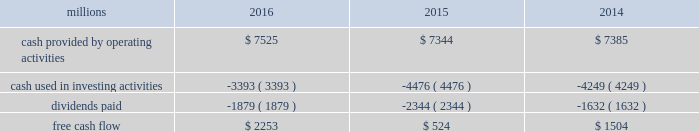To , rather than as a substitute for , cash provided by operating activities .
The table reconciles cash provided by operating activities ( gaap measure ) to free cash flow ( non-gaap measure ) : .
2017 outlook f0b7 safety 2013 operating a safe railroad benefits all our constituents : our employees , customers , shareholders and the communities we serve .
We will continue using a multi-faceted approach to safety , utilizing technology , risk assessment , training and employee engagement , quality control , and targeted capital investments .
We will continue using and expanding the deployment of total safety culture and courage to care throughout our operations , which allows us to identify and implement best practices for employee and operational safety .
We will continue our efforts to increase detection of rail defects ; improve or close crossings ; and educate the public and law enforcement agencies about crossing safety through a combination of our own programs ( including risk assessment strategies ) , industry programs and local community activities across our network .
F0b7 network operations 2013 in 2017 , we will continue to align resources with customer demand , maintain an efficient network , and ensure surge capability with our assets .
F0b7 fuel prices 2013 fuel price projections for crude oil and natural gas continue to fluctuate in the current environment .
We again could see volatile fuel prices during the year , as they are sensitive to global and u.s .
Domestic demand , refining capacity , geopolitical events , weather conditions and other factors .
As prices fluctuate , there will be a timing impact on earnings , as our fuel surcharge programs trail increases or decreases in fuel price by approximately two months .
Continuing lower fuel prices could have a positive impact on the economy by increasing consumer discretionary spending that potentially could increase demand for various consumer products that we transport .
Alternatively , lower fuel prices could likely have a negative impact on other commodities such as coal and domestic drilling-related shipments .
F0b7 capital plan 2013 in 2017 , we expect our capital plan to be approximately $ 3.1 billion , including expenditures for ptc , approximately 60 locomotives scheduled to be delivered , and intermodal containers and chassis , and freight cars .
The capital plan may be revised if business conditions warrant or if new laws or regulations affect our ability to generate sufficient returns on these investments .
( see further discussion in this item 7 under liquidity and capital resources 2013 capital plan. ) f0b7 financial expectations 2013 economic conditions in many of our market sectors continue to drive uncertainty with respect to our volume levels .
We expect volume to grow in the low single digit range in 2017 compared to 2016 , but it will depend on the overall economy and market conditions .
One of the more significant uncertainties is the outlook for energy markets , which will bring both challenges and opportunities .
In the current environment , we expect continued margin improvement driven by continued pricing opportunities , ongoing productivity initiatives , and the ability to leverage our resources and strengthen our franchise .
Over the longer term , we expect the overall u.s .
Economy to continue to improve at a modest pace , with some markets outperforming others. .
What was the percentage of dividends paid to cash provided by operating activities in 2016? 
Computations: (1879 / 7525)
Answer: 0.2497. 